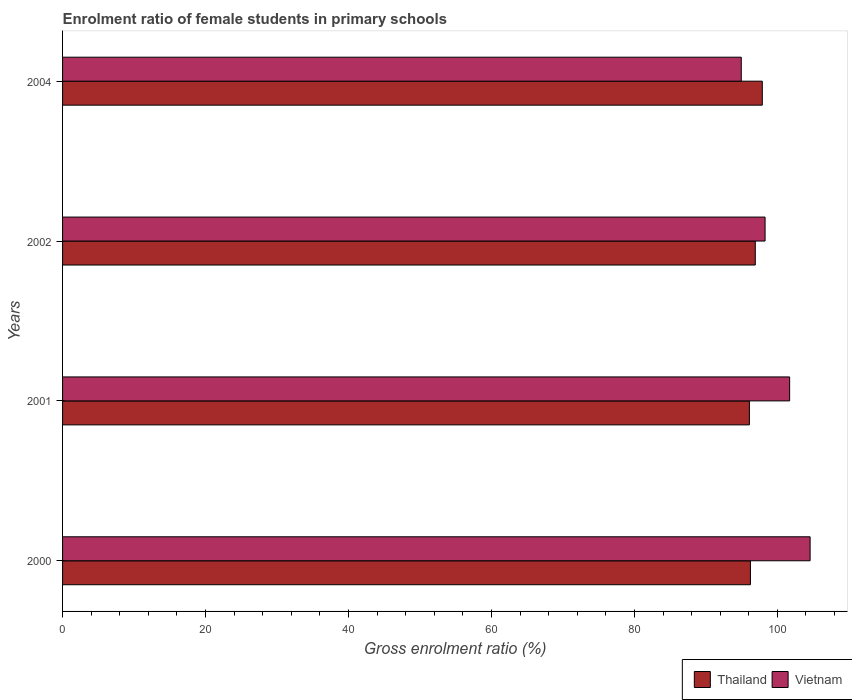How many different coloured bars are there?
Keep it short and to the point. 2. Are the number of bars on each tick of the Y-axis equal?
Give a very brief answer. Yes. How many bars are there on the 1st tick from the bottom?
Give a very brief answer. 2. What is the label of the 3rd group of bars from the top?
Keep it short and to the point. 2001. What is the enrolment ratio of female students in primary schools in Thailand in 2001?
Provide a short and direct response. 96.09. Across all years, what is the maximum enrolment ratio of female students in primary schools in Vietnam?
Your answer should be compact. 104.58. Across all years, what is the minimum enrolment ratio of female students in primary schools in Thailand?
Keep it short and to the point. 96.09. In which year was the enrolment ratio of female students in primary schools in Vietnam maximum?
Keep it short and to the point. 2000. In which year was the enrolment ratio of female students in primary schools in Vietnam minimum?
Give a very brief answer. 2004. What is the total enrolment ratio of female students in primary schools in Thailand in the graph?
Provide a succinct answer. 387.11. What is the difference between the enrolment ratio of female students in primary schools in Vietnam in 2002 and that in 2004?
Offer a terse response. 3.33. What is the difference between the enrolment ratio of female students in primary schools in Thailand in 2001 and the enrolment ratio of female students in primary schools in Vietnam in 2002?
Your answer should be very brief. -2.19. What is the average enrolment ratio of female students in primary schools in Thailand per year?
Your answer should be very brief. 96.78. In the year 2000, what is the difference between the enrolment ratio of female students in primary schools in Thailand and enrolment ratio of female students in primary schools in Vietnam?
Provide a succinct answer. -8.35. What is the ratio of the enrolment ratio of female students in primary schools in Thailand in 2000 to that in 2004?
Your answer should be very brief. 0.98. What is the difference between the highest and the second highest enrolment ratio of female students in primary schools in Vietnam?
Ensure brevity in your answer.  2.86. What is the difference between the highest and the lowest enrolment ratio of female students in primary schools in Thailand?
Provide a short and direct response. 1.8. In how many years, is the enrolment ratio of female students in primary schools in Thailand greater than the average enrolment ratio of female students in primary schools in Thailand taken over all years?
Your answer should be compact. 2. Is the sum of the enrolment ratio of female students in primary schools in Thailand in 2000 and 2002 greater than the maximum enrolment ratio of female students in primary schools in Vietnam across all years?
Provide a short and direct response. Yes. What does the 1st bar from the top in 2000 represents?
Your answer should be compact. Vietnam. What does the 1st bar from the bottom in 2004 represents?
Give a very brief answer. Thailand. How many bars are there?
Your response must be concise. 8. Are all the bars in the graph horizontal?
Give a very brief answer. Yes. What is the difference between two consecutive major ticks on the X-axis?
Provide a short and direct response. 20. Does the graph contain any zero values?
Offer a very short reply. No. Does the graph contain grids?
Your response must be concise. No. What is the title of the graph?
Keep it short and to the point. Enrolment ratio of female students in primary schools. What is the label or title of the X-axis?
Offer a terse response. Gross enrolment ratio (%). What is the Gross enrolment ratio (%) of Thailand in 2000?
Ensure brevity in your answer.  96.23. What is the Gross enrolment ratio (%) in Vietnam in 2000?
Make the answer very short. 104.58. What is the Gross enrolment ratio (%) of Thailand in 2001?
Ensure brevity in your answer.  96.09. What is the Gross enrolment ratio (%) in Vietnam in 2001?
Your answer should be compact. 101.72. What is the Gross enrolment ratio (%) in Thailand in 2002?
Make the answer very short. 96.91. What is the Gross enrolment ratio (%) in Vietnam in 2002?
Keep it short and to the point. 98.28. What is the Gross enrolment ratio (%) in Thailand in 2004?
Keep it short and to the point. 97.89. What is the Gross enrolment ratio (%) of Vietnam in 2004?
Your answer should be compact. 94.95. Across all years, what is the maximum Gross enrolment ratio (%) of Thailand?
Give a very brief answer. 97.89. Across all years, what is the maximum Gross enrolment ratio (%) in Vietnam?
Offer a terse response. 104.58. Across all years, what is the minimum Gross enrolment ratio (%) in Thailand?
Offer a very short reply. 96.09. Across all years, what is the minimum Gross enrolment ratio (%) of Vietnam?
Offer a terse response. 94.95. What is the total Gross enrolment ratio (%) in Thailand in the graph?
Your answer should be very brief. 387.11. What is the total Gross enrolment ratio (%) in Vietnam in the graph?
Your answer should be compact. 399.52. What is the difference between the Gross enrolment ratio (%) in Thailand in 2000 and that in 2001?
Offer a very short reply. 0.14. What is the difference between the Gross enrolment ratio (%) in Vietnam in 2000 and that in 2001?
Offer a terse response. 2.86. What is the difference between the Gross enrolment ratio (%) of Thailand in 2000 and that in 2002?
Ensure brevity in your answer.  -0.68. What is the difference between the Gross enrolment ratio (%) of Vietnam in 2000 and that in 2002?
Offer a terse response. 6.3. What is the difference between the Gross enrolment ratio (%) in Thailand in 2000 and that in 2004?
Keep it short and to the point. -1.66. What is the difference between the Gross enrolment ratio (%) in Vietnam in 2000 and that in 2004?
Provide a short and direct response. 9.63. What is the difference between the Gross enrolment ratio (%) in Thailand in 2001 and that in 2002?
Give a very brief answer. -0.82. What is the difference between the Gross enrolment ratio (%) of Vietnam in 2001 and that in 2002?
Offer a very short reply. 3.44. What is the difference between the Gross enrolment ratio (%) of Thailand in 2001 and that in 2004?
Make the answer very short. -1.8. What is the difference between the Gross enrolment ratio (%) in Vietnam in 2001 and that in 2004?
Offer a terse response. 6.77. What is the difference between the Gross enrolment ratio (%) of Thailand in 2002 and that in 2004?
Offer a very short reply. -0.98. What is the difference between the Gross enrolment ratio (%) in Vietnam in 2002 and that in 2004?
Your answer should be compact. 3.33. What is the difference between the Gross enrolment ratio (%) of Thailand in 2000 and the Gross enrolment ratio (%) of Vietnam in 2001?
Provide a short and direct response. -5.49. What is the difference between the Gross enrolment ratio (%) in Thailand in 2000 and the Gross enrolment ratio (%) in Vietnam in 2002?
Your answer should be compact. -2.05. What is the difference between the Gross enrolment ratio (%) of Thailand in 2000 and the Gross enrolment ratio (%) of Vietnam in 2004?
Your response must be concise. 1.28. What is the difference between the Gross enrolment ratio (%) of Thailand in 2001 and the Gross enrolment ratio (%) of Vietnam in 2002?
Provide a succinct answer. -2.19. What is the difference between the Gross enrolment ratio (%) of Thailand in 2001 and the Gross enrolment ratio (%) of Vietnam in 2004?
Your response must be concise. 1.14. What is the difference between the Gross enrolment ratio (%) in Thailand in 2002 and the Gross enrolment ratio (%) in Vietnam in 2004?
Provide a succinct answer. 1.96. What is the average Gross enrolment ratio (%) in Thailand per year?
Give a very brief answer. 96.78. What is the average Gross enrolment ratio (%) of Vietnam per year?
Provide a succinct answer. 99.88. In the year 2000, what is the difference between the Gross enrolment ratio (%) in Thailand and Gross enrolment ratio (%) in Vietnam?
Provide a succinct answer. -8.35. In the year 2001, what is the difference between the Gross enrolment ratio (%) in Thailand and Gross enrolment ratio (%) in Vietnam?
Your response must be concise. -5.63. In the year 2002, what is the difference between the Gross enrolment ratio (%) in Thailand and Gross enrolment ratio (%) in Vietnam?
Your answer should be compact. -1.37. In the year 2004, what is the difference between the Gross enrolment ratio (%) in Thailand and Gross enrolment ratio (%) in Vietnam?
Your answer should be compact. 2.94. What is the ratio of the Gross enrolment ratio (%) of Vietnam in 2000 to that in 2001?
Your response must be concise. 1.03. What is the ratio of the Gross enrolment ratio (%) in Vietnam in 2000 to that in 2002?
Give a very brief answer. 1.06. What is the ratio of the Gross enrolment ratio (%) in Vietnam in 2000 to that in 2004?
Ensure brevity in your answer.  1.1. What is the ratio of the Gross enrolment ratio (%) of Thailand in 2001 to that in 2002?
Your response must be concise. 0.99. What is the ratio of the Gross enrolment ratio (%) of Vietnam in 2001 to that in 2002?
Keep it short and to the point. 1.03. What is the ratio of the Gross enrolment ratio (%) of Thailand in 2001 to that in 2004?
Provide a short and direct response. 0.98. What is the ratio of the Gross enrolment ratio (%) in Vietnam in 2001 to that in 2004?
Give a very brief answer. 1.07. What is the ratio of the Gross enrolment ratio (%) of Thailand in 2002 to that in 2004?
Ensure brevity in your answer.  0.99. What is the ratio of the Gross enrolment ratio (%) in Vietnam in 2002 to that in 2004?
Offer a very short reply. 1.04. What is the difference between the highest and the second highest Gross enrolment ratio (%) in Thailand?
Provide a short and direct response. 0.98. What is the difference between the highest and the second highest Gross enrolment ratio (%) of Vietnam?
Ensure brevity in your answer.  2.86. What is the difference between the highest and the lowest Gross enrolment ratio (%) in Thailand?
Give a very brief answer. 1.8. What is the difference between the highest and the lowest Gross enrolment ratio (%) in Vietnam?
Offer a terse response. 9.63. 